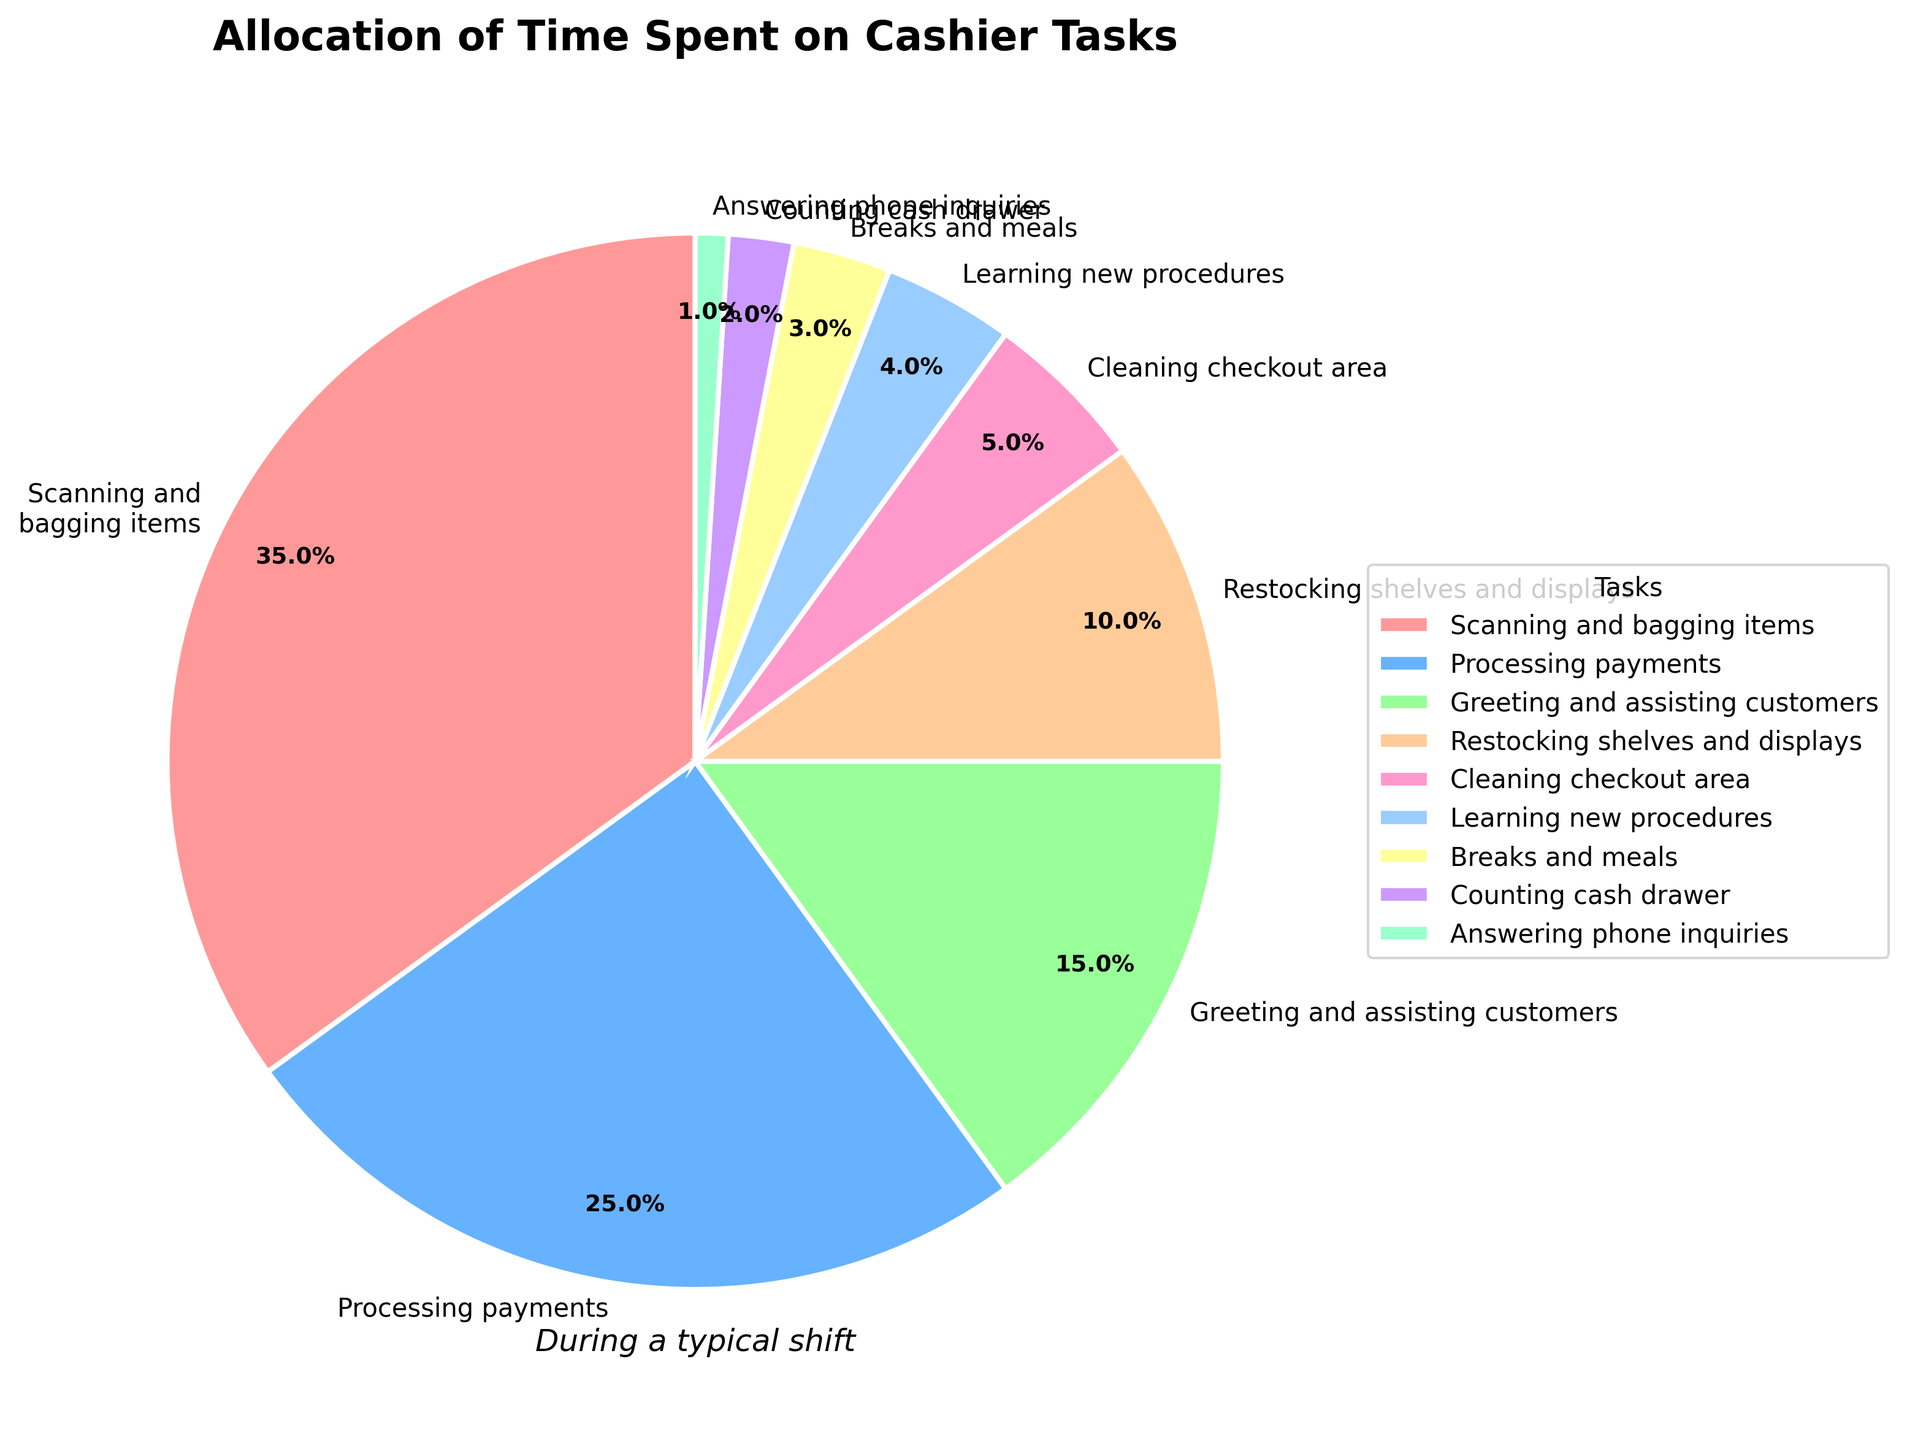What task takes up the largest portion of the cashier's time? By looking at the pie chart, the largest section visually represents the task with the highest percentage. This section is labeled as "Scanning and bagging items," which makes up 35% of the cashier's time.
Answer: Scanning and bagging items How much time is spent on greeting and assisting customers compared to counting the cash drawer? The pie chart shows "Greeting and assisting customers" at 15% and "Counting cash drawer" at 2%. The difference is 15% - 2% = 13%, showing more time is spent on greeting and assisting customers than counting the cash drawer.
Answer: 13% What percentage of time is allocated to activities other than scanning and bagging items? To find the time spent on other tasks, sum the percentages of all tasks except for "Scanning and bagging items." This total is 25% + 15% + 10% + 5% + 4% + 3% + 2% + 1% = 65%.
Answer: 65% Which task takes up less time, cleaning the checkout area or learning new procedures? The pie chart indicates "Cleaning checkout area" occupies 5% of the time and "Learning new procedures" occupies 4%. Comparing these values shows that learning new procedures takes up less time.
Answer: Learning new procedures What is the combined percentage of time spent on restocking shelves and answering phone inquiries? The pie chart shows "Restocking shelves and displays" at 10% and "Answering phone inquiries" at 1%. Adding these percentages gives 10% + 1% = 11%.
Answer: 11% What are the three tasks with the least amount of time allocated to them? The pie chart's smallest sections represent the tasks with the least time. These are labeled "Answering phone inquiries" at 1%, "Counting cash drawer" at 2%, and "Breaks and meals" at 3%.
Answer: Answering phone inquiries, Counting cash drawer, Breaks and meals Which tasks together make up 50% of the time spent? From the pie chart, the tasks "Scanning and bagging items" (35%) and "Processing payments" (25%) sum to 35% + 25% = 60%. Continuing to add, "Greeting and assisting customers" adds another 15%, but the combined already exceeds 50%. Only "Scanning and bagging items" and "Processing payments" together exceed 50%.
Answer: Scanning and bagging items, Processing payments How do the combined activities of greeting customers, restocking, and cleaning compare to the time spent scanning and bagging? The pie chart shows "Greeting and assisting customers" at 15%, "Restocking shelves and displays" at 10%, and "Cleaning checkout area" at 5%. Summing these gives 15% + 10% + 5% = 30%, which is less than the 35% spent on "Scanning and bagging items."
Answer: Less What is the percentage difference between the task taking the most time and the task taking the least time? The pie chart shows "Scanning and bagging items" at 35% and "Answering phone inquiries" at 1%. The difference is 35% - 1% = 34%.
Answer: 34% What percentage of the total shift is allocated to breaks and counting cash drawer combined? The pie chart indicates "Breaks and meals" at 3% and "Counting cash drawer" at 2%. Adding these percentages gives 3% + 2% = 5%.
Answer: 5% 